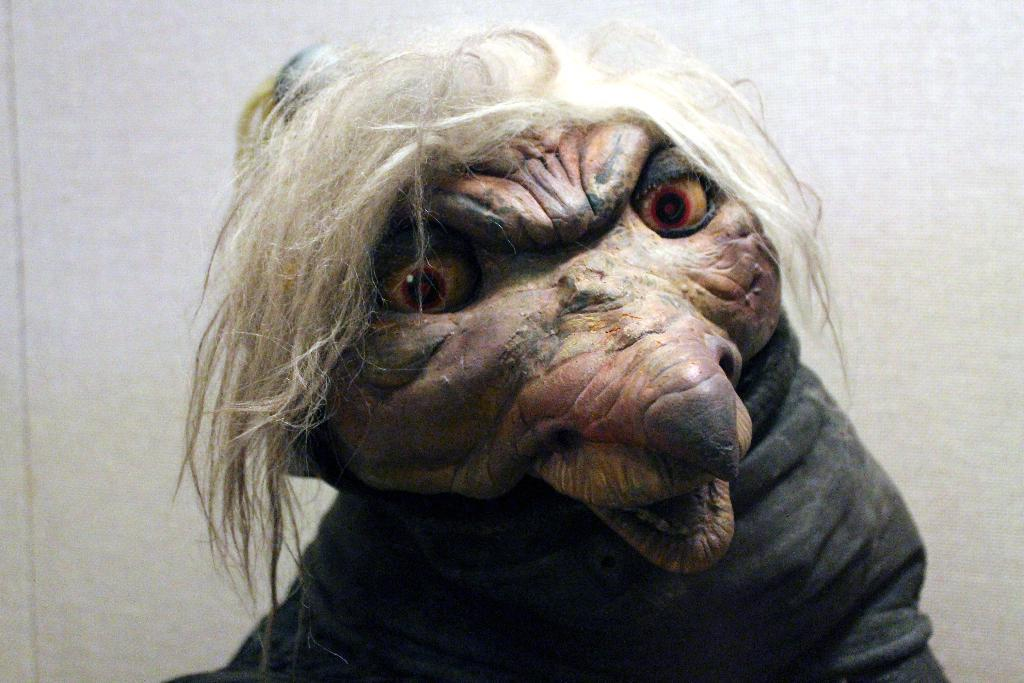What is the shape of the toy in the image? The toy is in the shape of a monster. How many eyes does the toy have? The toy has two eyes. What feature does the toy have that resembles human hair? The toy has hair. What type of mint is growing on the toy's head in the image? There is no mint growing on the toy's head in the image; it is a toy with hair. Can you tell me how many books the toy is exchanging with another toy in the image? There is no exchange of books or interaction with another toy depicted in the image. 